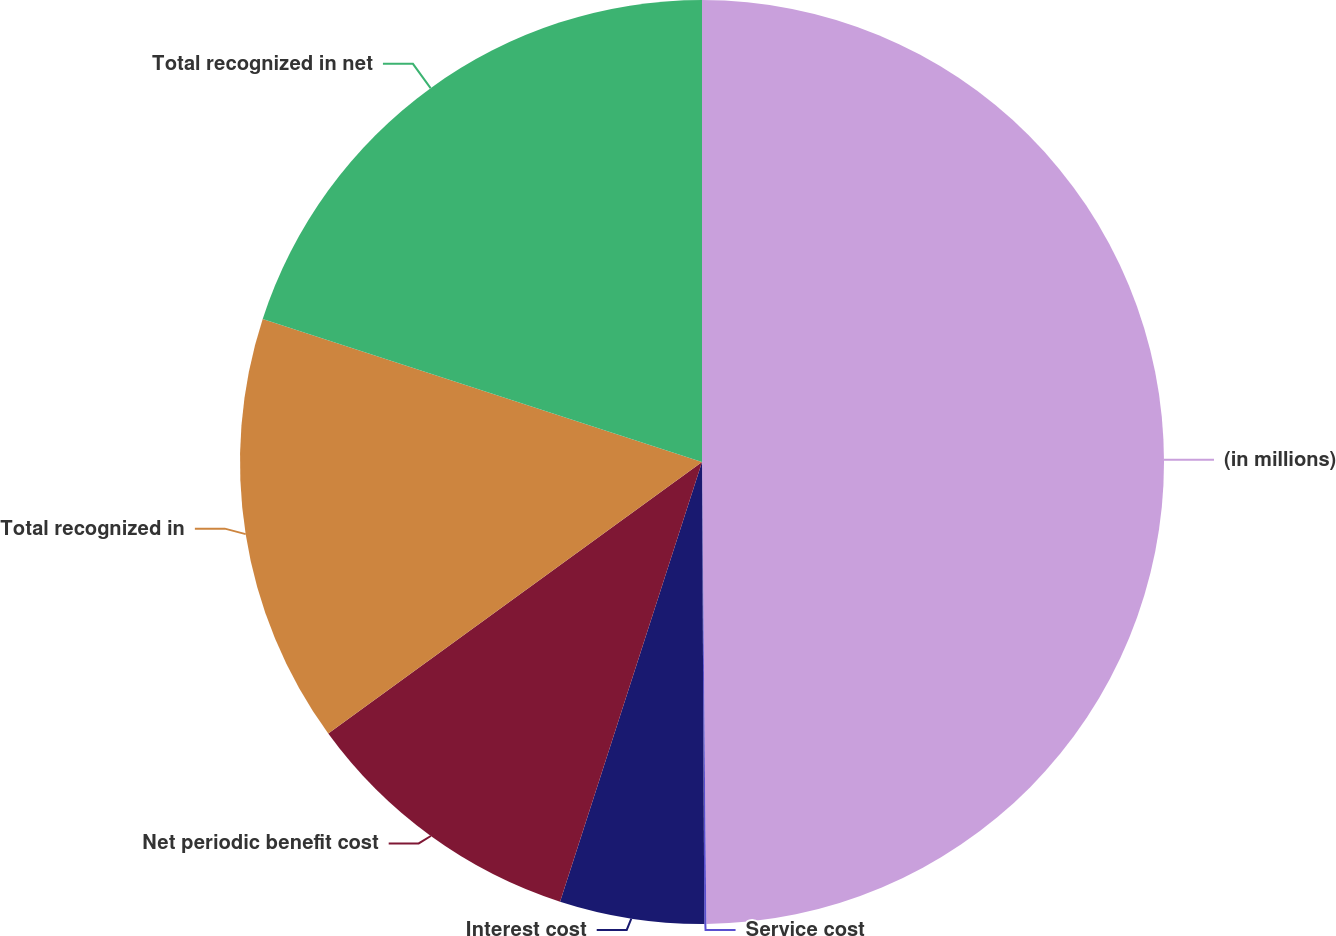<chart> <loc_0><loc_0><loc_500><loc_500><pie_chart><fcel>(in millions)<fcel>Service cost<fcel>Interest cost<fcel>Net periodic benefit cost<fcel>Total recognized in<fcel>Total recognized in net<nl><fcel>49.85%<fcel>0.07%<fcel>5.05%<fcel>10.03%<fcel>15.01%<fcel>19.99%<nl></chart> 